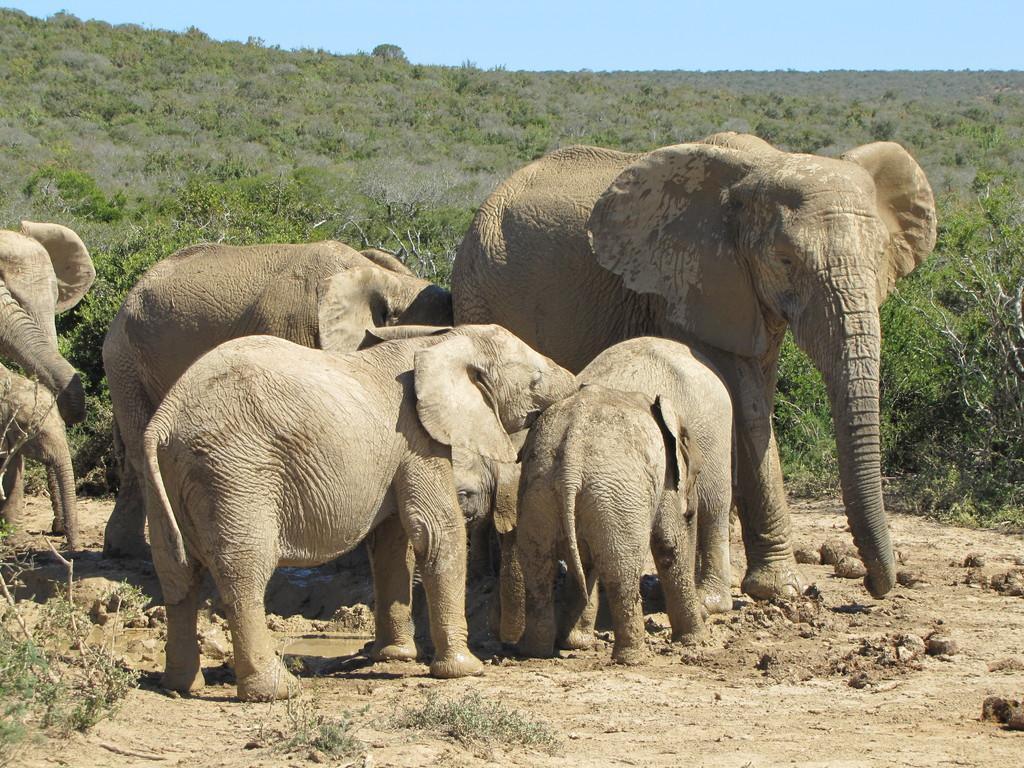How would you summarize this image in a sentence or two? A herd of elephants are standing in the middle. In the long back side of an image there are trees. 